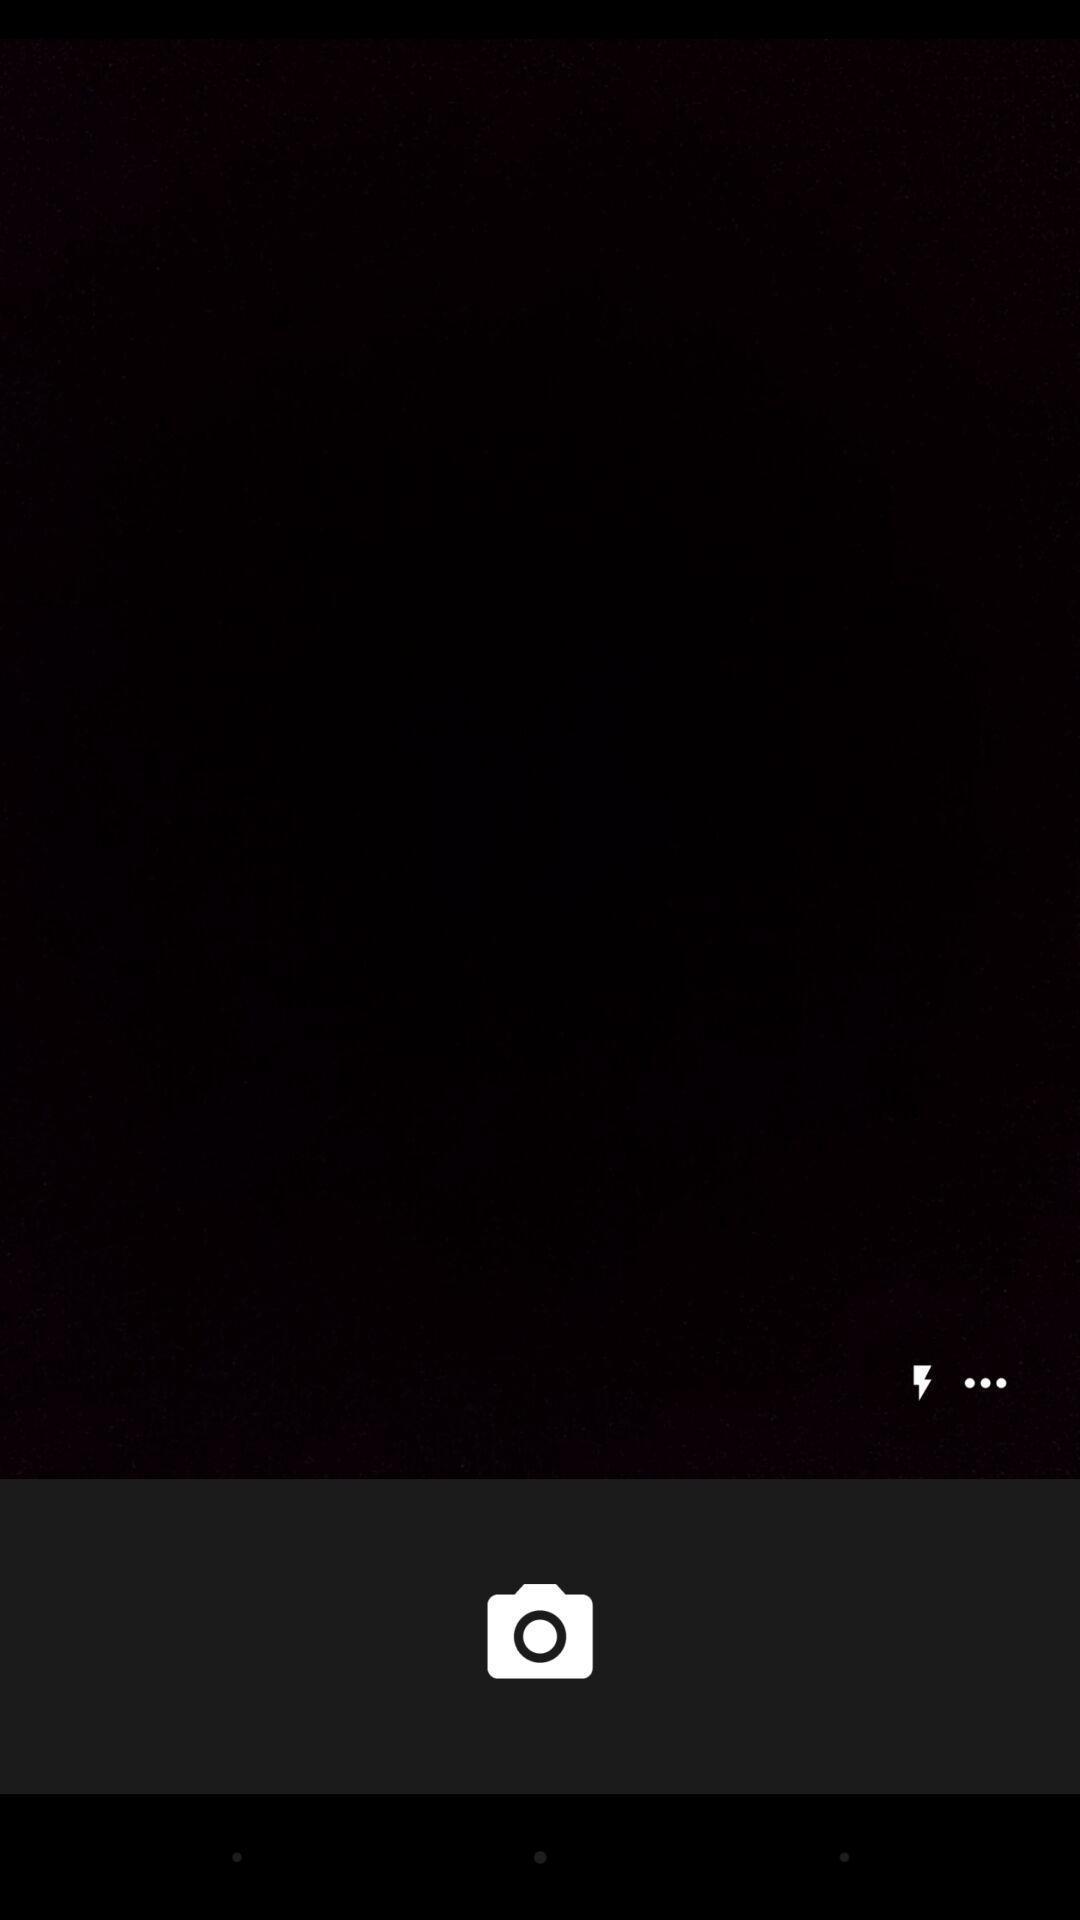Provide a detailed account of this screenshot. Screen displaying the camera icon and other options. 